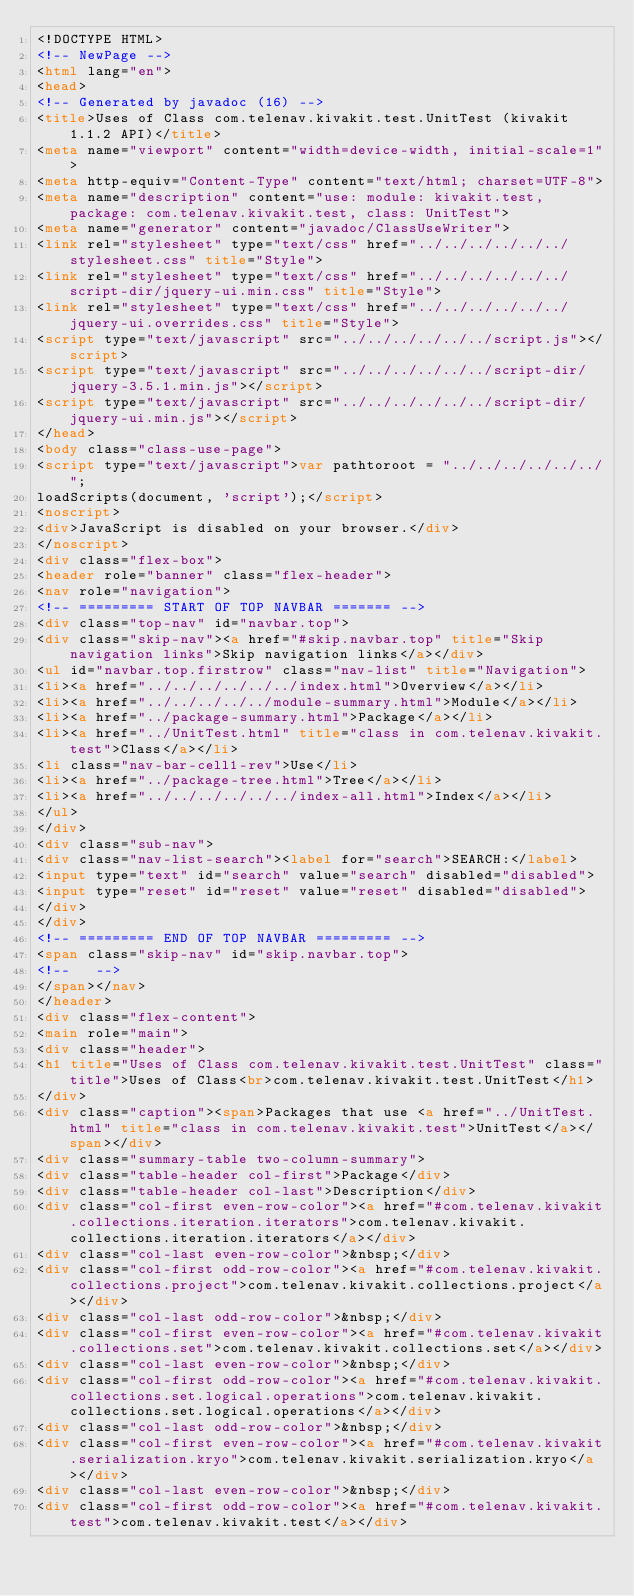Convert code to text. <code><loc_0><loc_0><loc_500><loc_500><_HTML_><!DOCTYPE HTML>
<!-- NewPage -->
<html lang="en">
<head>
<!-- Generated by javadoc (16) -->
<title>Uses of Class com.telenav.kivakit.test.UnitTest (kivakit 1.1.2 API)</title>
<meta name="viewport" content="width=device-width, initial-scale=1">
<meta http-equiv="Content-Type" content="text/html; charset=UTF-8">
<meta name="description" content="use: module: kivakit.test, package: com.telenav.kivakit.test, class: UnitTest">
<meta name="generator" content="javadoc/ClassUseWriter">
<link rel="stylesheet" type="text/css" href="../../../../../../stylesheet.css" title="Style">
<link rel="stylesheet" type="text/css" href="../../../../../../script-dir/jquery-ui.min.css" title="Style">
<link rel="stylesheet" type="text/css" href="../../../../../../jquery-ui.overrides.css" title="Style">
<script type="text/javascript" src="../../../../../../script.js"></script>
<script type="text/javascript" src="../../../../../../script-dir/jquery-3.5.1.min.js"></script>
<script type="text/javascript" src="../../../../../../script-dir/jquery-ui.min.js"></script>
</head>
<body class="class-use-page">
<script type="text/javascript">var pathtoroot = "../../../../../../";
loadScripts(document, 'script');</script>
<noscript>
<div>JavaScript is disabled on your browser.</div>
</noscript>
<div class="flex-box">
<header role="banner" class="flex-header">
<nav role="navigation">
<!-- ========= START OF TOP NAVBAR ======= -->
<div class="top-nav" id="navbar.top">
<div class="skip-nav"><a href="#skip.navbar.top" title="Skip navigation links">Skip navigation links</a></div>
<ul id="navbar.top.firstrow" class="nav-list" title="Navigation">
<li><a href="../../../../../../index.html">Overview</a></li>
<li><a href="../../../../../module-summary.html">Module</a></li>
<li><a href="../package-summary.html">Package</a></li>
<li><a href="../UnitTest.html" title="class in com.telenav.kivakit.test">Class</a></li>
<li class="nav-bar-cell1-rev">Use</li>
<li><a href="../package-tree.html">Tree</a></li>
<li><a href="../../../../../../index-all.html">Index</a></li>
</ul>
</div>
<div class="sub-nav">
<div class="nav-list-search"><label for="search">SEARCH:</label>
<input type="text" id="search" value="search" disabled="disabled">
<input type="reset" id="reset" value="reset" disabled="disabled">
</div>
</div>
<!-- ========= END OF TOP NAVBAR ========= -->
<span class="skip-nav" id="skip.navbar.top">
<!--   -->
</span></nav>
</header>
<div class="flex-content">
<main role="main">
<div class="header">
<h1 title="Uses of Class com.telenav.kivakit.test.UnitTest" class="title">Uses of Class<br>com.telenav.kivakit.test.UnitTest</h1>
</div>
<div class="caption"><span>Packages that use <a href="../UnitTest.html" title="class in com.telenav.kivakit.test">UnitTest</a></span></div>
<div class="summary-table two-column-summary">
<div class="table-header col-first">Package</div>
<div class="table-header col-last">Description</div>
<div class="col-first even-row-color"><a href="#com.telenav.kivakit.collections.iteration.iterators">com.telenav.kivakit.collections.iteration.iterators</a></div>
<div class="col-last even-row-color">&nbsp;</div>
<div class="col-first odd-row-color"><a href="#com.telenav.kivakit.collections.project">com.telenav.kivakit.collections.project</a></div>
<div class="col-last odd-row-color">&nbsp;</div>
<div class="col-first even-row-color"><a href="#com.telenav.kivakit.collections.set">com.telenav.kivakit.collections.set</a></div>
<div class="col-last even-row-color">&nbsp;</div>
<div class="col-first odd-row-color"><a href="#com.telenav.kivakit.collections.set.logical.operations">com.telenav.kivakit.collections.set.logical.operations</a></div>
<div class="col-last odd-row-color">&nbsp;</div>
<div class="col-first even-row-color"><a href="#com.telenav.kivakit.serialization.kryo">com.telenav.kivakit.serialization.kryo</a></div>
<div class="col-last even-row-color">&nbsp;</div>
<div class="col-first odd-row-color"><a href="#com.telenav.kivakit.test">com.telenav.kivakit.test</a></div></code> 